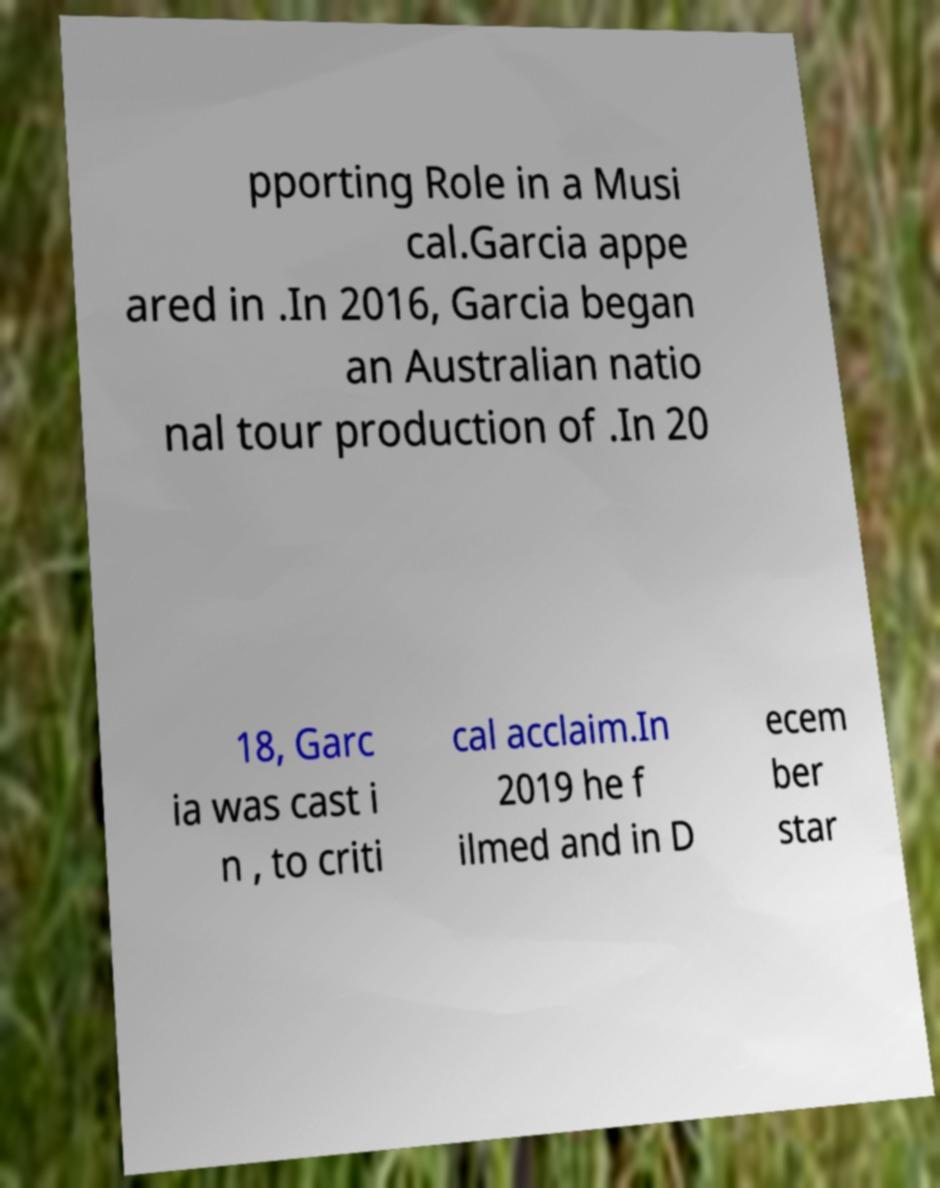There's text embedded in this image that I need extracted. Can you transcribe it verbatim? pporting Role in a Musi cal.Garcia appe ared in .In 2016, Garcia began an Australian natio nal tour production of .In 20 18, Garc ia was cast i n , to criti cal acclaim.In 2019 he f ilmed and in D ecem ber star 